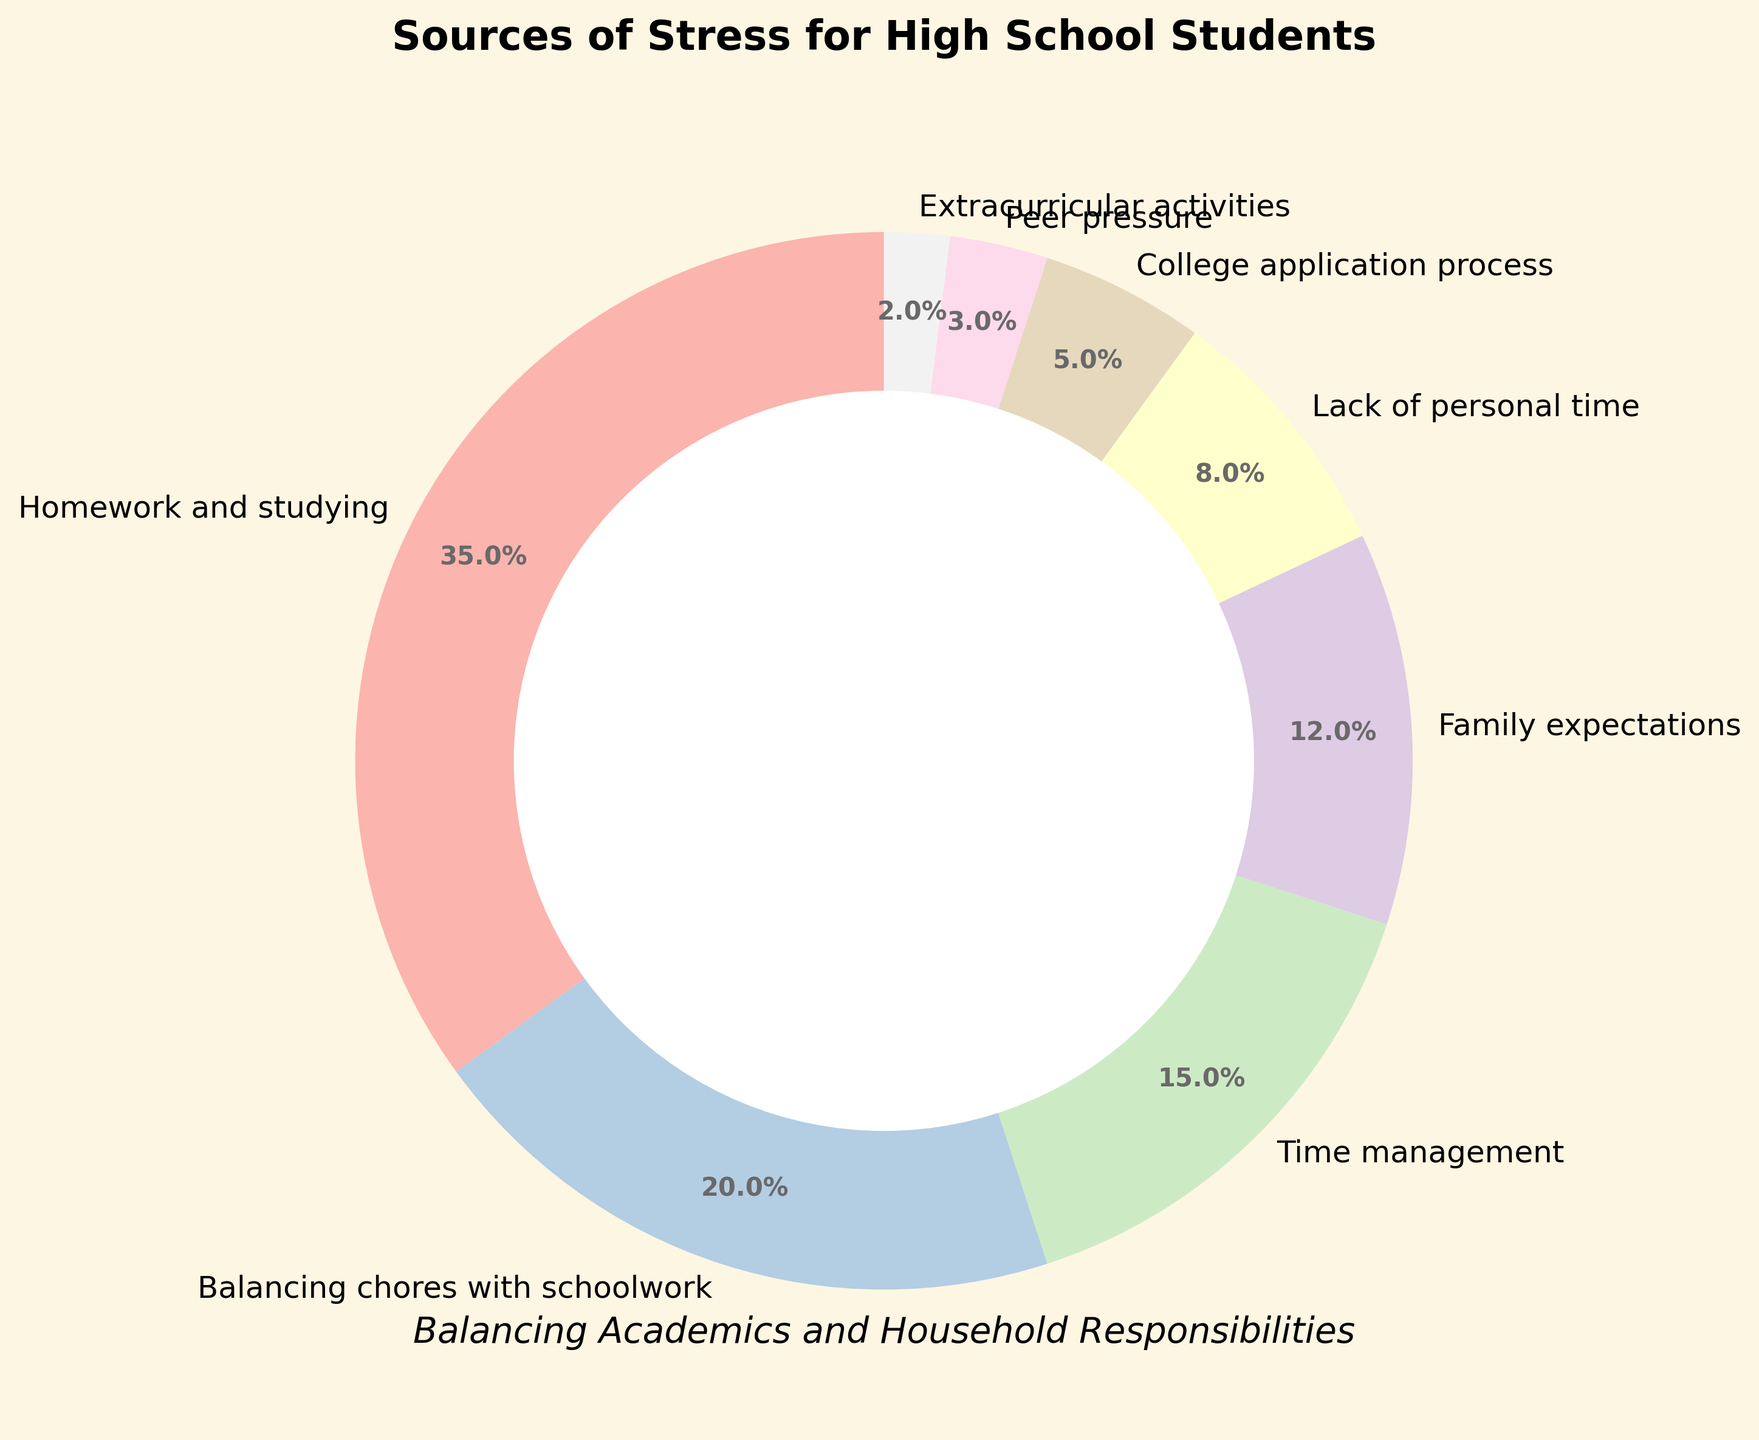Which stress source has the highest percentage? To find the source of stress with the highest percentage, look at the segments of the pie chart and their labels. The largest portion is typically the section with the highest label percentage. In this case, "Homework and studying" has the largest segment labeled 35%.
Answer: Homework and studying How much greater is the percentage of stress from homework and studying compared to balancing chores with schoolwork? First, identify the percentages for both sources: Homework and studying is 35%, and balancing chores with schoolwork is 20%. Subtract the smaller percentage from the larger one: 35% - 20% = 15%.
Answer: 15% What is the combined percentage of stress from family expectations and lack of personal time? Add the percentages for family expectations and lack of personal time: Family expectations is 12%, and lack of personal time is 8%. The sum is 12% + 8% = 20%.
Answer: 20% What is the least common source of stress according to the chart? Look for the segment with the smallest percentage. The pie segment labeled "Extracurricular activities" shows the smallest value, which is 2%.
Answer: Extracurricular activities Which stress source is represented by the third-largest segment? Identify and compare the sizes of the pie segments. The third-largest segment corresponds to "Time management" which is labeled with 15%.
Answer: Time management How much total stress percentage is contributed by both peer pressure and the college application process? Peer pressure is 3%, and the college application process is 5%. Adding these together: 3% + 5% = 8%.
Answer: 8% What stress sources have percentages greater than 10%? Scan the chart for segments with percentages higher than 10%. The stress sources are Homework and studying (35%), Balancing chores with schoolwork (20%), and Family expectations (12%).
Answer: Homework and studying, Balancing chores with schoolwork, Family expectations 